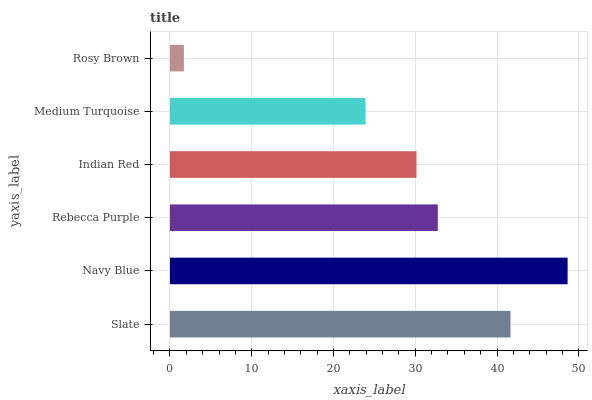Is Rosy Brown the minimum?
Answer yes or no. Yes. Is Navy Blue the maximum?
Answer yes or no. Yes. Is Rebecca Purple the minimum?
Answer yes or no. No. Is Rebecca Purple the maximum?
Answer yes or no. No. Is Navy Blue greater than Rebecca Purple?
Answer yes or no. Yes. Is Rebecca Purple less than Navy Blue?
Answer yes or no. Yes. Is Rebecca Purple greater than Navy Blue?
Answer yes or no. No. Is Navy Blue less than Rebecca Purple?
Answer yes or no. No. Is Rebecca Purple the high median?
Answer yes or no. Yes. Is Indian Red the low median?
Answer yes or no. Yes. Is Rosy Brown the high median?
Answer yes or no. No. Is Rosy Brown the low median?
Answer yes or no. No. 